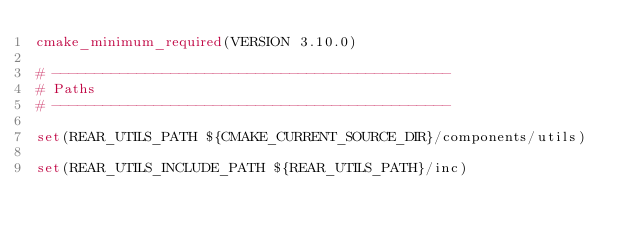Convert code to text. <code><loc_0><loc_0><loc_500><loc_500><_CMake_>cmake_minimum_required(VERSION 3.10.0)

# -----------------------------------------------
# Paths
# -----------------------------------------------

set(REAR_UTILS_PATH ${CMAKE_CURRENT_SOURCE_DIR}/components/utils)

set(REAR_UTILS_INCLUDE_PATH ${REAR_UTILS_PATH}/inc)
</code> 